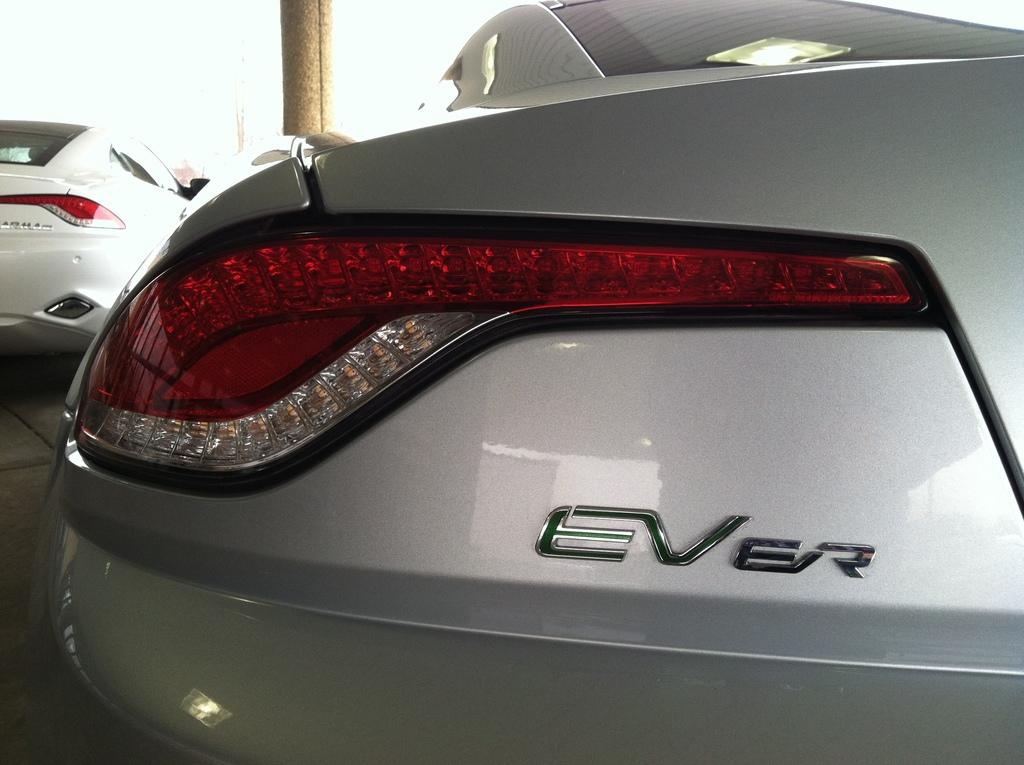What is the main subject of the image? The main subject of the image is a car. Can you describe the level of detail in the image? The image is a zoomed in picture of the car, which means it provides a close-up view of the car's features. What type of toys can be seen in the car's trunk in the image? There are no toys visible in the image; it is a zoomed in picture of a car, not a toy car or a car with toys in the trunk. 